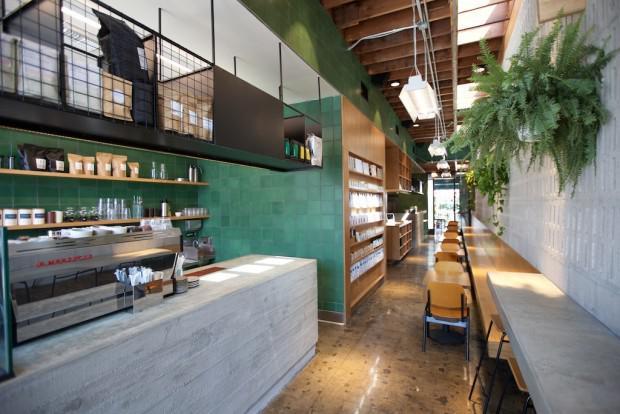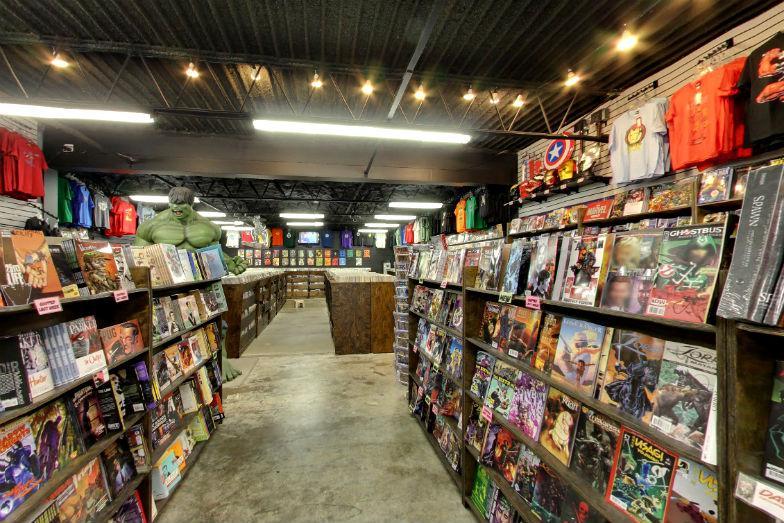The first image is the image on the left, the second image is the image on the right. Evaluate the accuracy of this statement regarding the images: "In the bookstore there is a single green plant hanging from the brown triangle roof pattern.". Is it true? Answer yes or no. No. The first image is the image on the left, the second image is the image on the right. Given the left and right images, does the statement "Green foliage is hanging over bookshelves in a shop with diamond shapes in light wood on the upper part." hold true? Answer yes or no. No. 